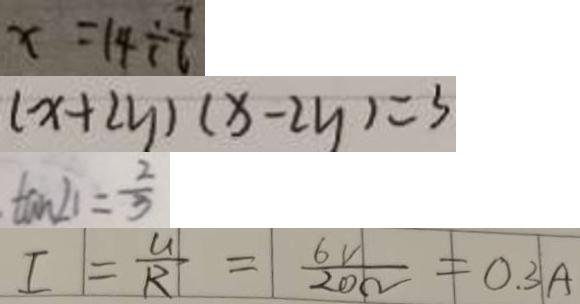Convert formula to latex. <formula><loc_0><loc_0><loc_500><loc_500>x = 1 4 \div \frac { 7 } { 6 } 
 ( x + 2 y ) ( x - 2 y ) = 3 
 \tan \angle 1 = \frac { 2 } { 3 } 
 I = \frac { U } { R } = \frac { 6 V } { 2 0 \Omega } = 0 . 3 A</formula> 